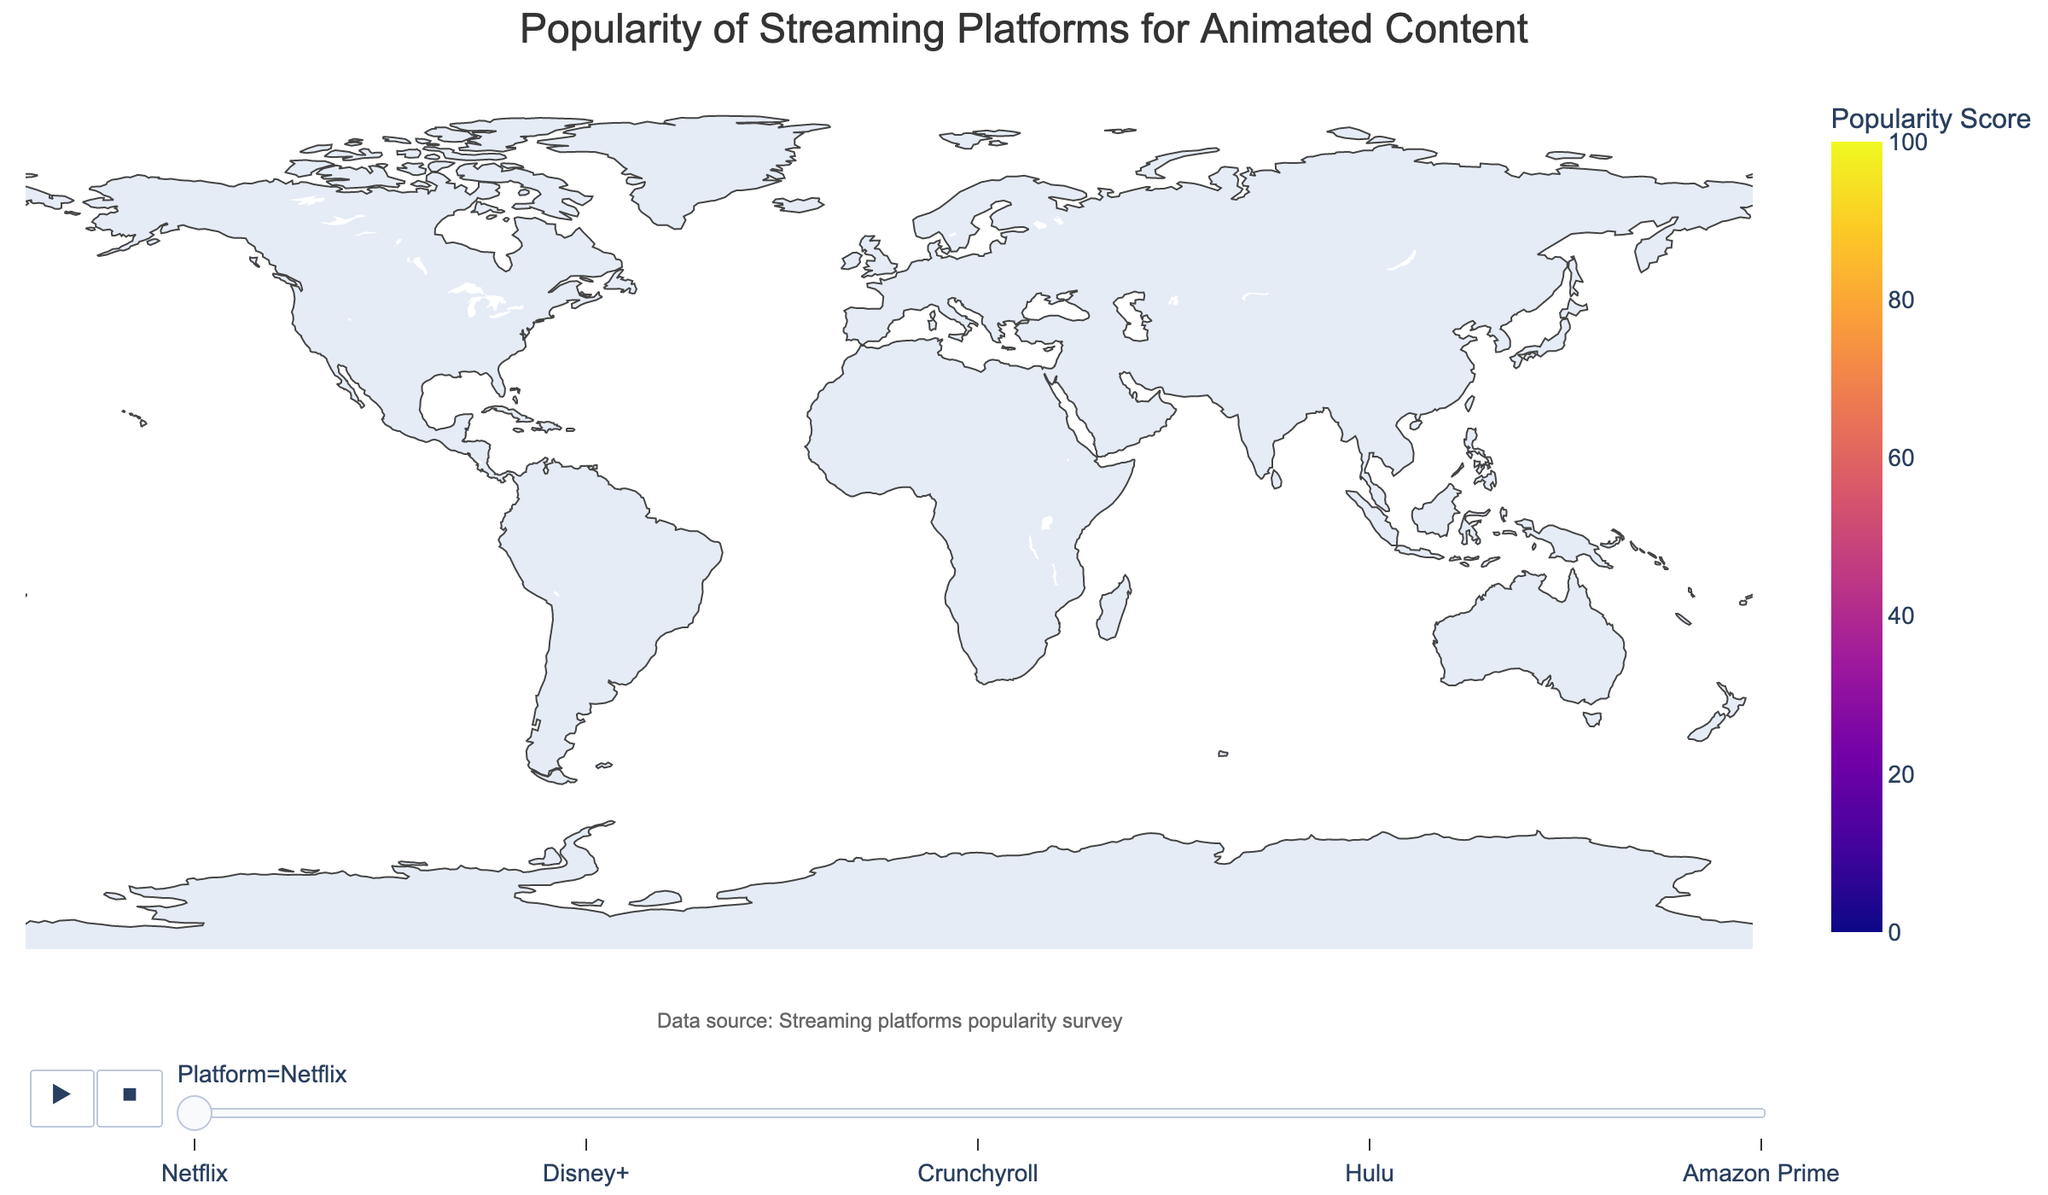What is the title of the figure? The title is typically displayed at the top of the figure to summarize the main content. Here, the title is meant to describe the distribution of popularity scores for streaming platforms across different regions.
Answer: Popularity of Streaming Platforms for Animated Content Which country has the highest popularity score for Netflix? Each animated frame in the figure highlights different platforms. By looking at the frame for Netflix, the United States has the highest value of 85.
Answer: United States How does Crunchyroll's popularity in Japan compare to the United States? By examining the Crunchyroll frame, we see Japan's value is 78 and the United States' is 45, indicating higher popularity in Japan.
Answer: Higher in Japan How many countries have a greater popularity score for Disney+ than Hulu? The countries listed are United States, Canada, United Kingdom, Brazil, Germany, France, Australia, Mexico, South Korea, and Japan. In all these countries except the United States and Canada, Hulu’s score is 0, making Disney+ popularity score higher in those 8 countries.
Answer: 8 What is the colorbar title, and what does it represent? The colorbar title is typically placed beside the color scale and indicates what the colors represent. Here, it is "Popularity Score" showing the intensity of colors reflects popularity levels.
Answer: Popularity Score What is the range of popularity scores represented in the color scale? The figure defines color representation from a continuous scale, ranging from the minimum to the maximum popularity scores present, as indicated in the code with `range_color=[0, 100]`.
Answer: 0 to 100 Which streaming platform has no popularity in some countries, and what could be a reason? By observing the animation frames, Hulu has a score of 0 in several countries: Japan, United Kingdom, Brazil, Germany, France, Australia, Mexico, and South Korea. Perhaps it is not available in these markets.
Answer: Hulu; Possibly not available What is the average popularity score of Amazon Prime across all countries? Adding popularity scores from the given data for Amazon Prime: (52 + 41 + 58 + 45 + 49 + 42 + 50 + 48 + 38 + 35), results in 458. Dividing by the number of countries (10), the average is 458 / 10.
Answer: 45.8 Which platform is least popular in South Korea? By viewing South Korea's data in the animated frames, Amazon Prime has the lowest score of 35.
Answer: Amazon Prime For which platform is Brazil's popularity score closest to its average popularity score across all countries? First, compute Brazil's popularity scores: Netflix 70, Disney+ 58, Crunchyroll 25, Hulu 0, Amazon Prime 45. Now find the averages: 75.3, 51.4, 36, 6, and 45. Compare Brazil's scores to these averages for each platform. Disney+ score (58) is closest to 51.4.
Answer: Disney+ 